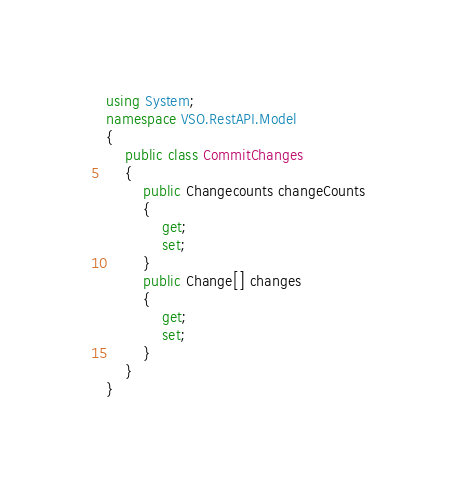<code> <loc_0><loc_0><loc_500><loc_500><_C#_>using System;
namespace VSO.RestAPI.Model
{
	public class CommitChanges
	{
		public Changecounts changeCounts
		{
			get;
			set;
		}
		public Change[] changes
		{
			get;
			set;
		}
	}
}
</code> 